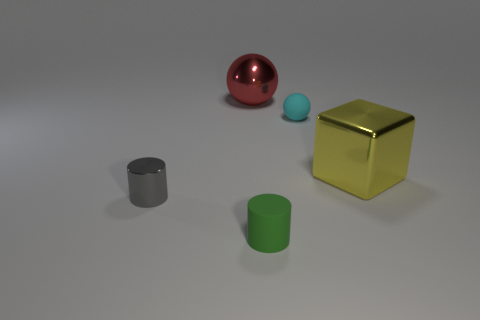Are there any matte spheres that have the same color as the metal cylinder?
Offer a very short reply. No. How many large objects are yellow shiny cubes or yellow metal cylinders?
Make the answer very short. 1. Are the cylinder that is on the right side of the gray shiny object and the small gray object made of the same material?
Offer a terse response. No. What is the shape of the tiny object that is behind the small shiny cylinder that is left of the metal thing on the right side of the small green thing?
Offer a very short reply. Sphere. What number of yellow things are either rubber spheres or metal cubes?
Provide a short and direct response. 1. Are there an equal number of tiny green matte things that are on the right side of the yellow thing and cyan rubber things right of the small ball?
Your answer should be very brief. Yes. There is a small matte object that is left of the tiny matte ball; is it the same shape as the rubber thing that is right of the green matte object?
Keep it short and to the point. No. Are there any other things that are the same shape as the red thing?
Your answer should be very brief. Yes. There is a small gray object that is made of the same material as the big yellow thing; what shape is it?
Give a very brief answer. Cylinder. Is the number of tiny gray cylinders to the left of the cyan object the same as the number of big metallic cubes?
Offer a very short reply. Yes. 